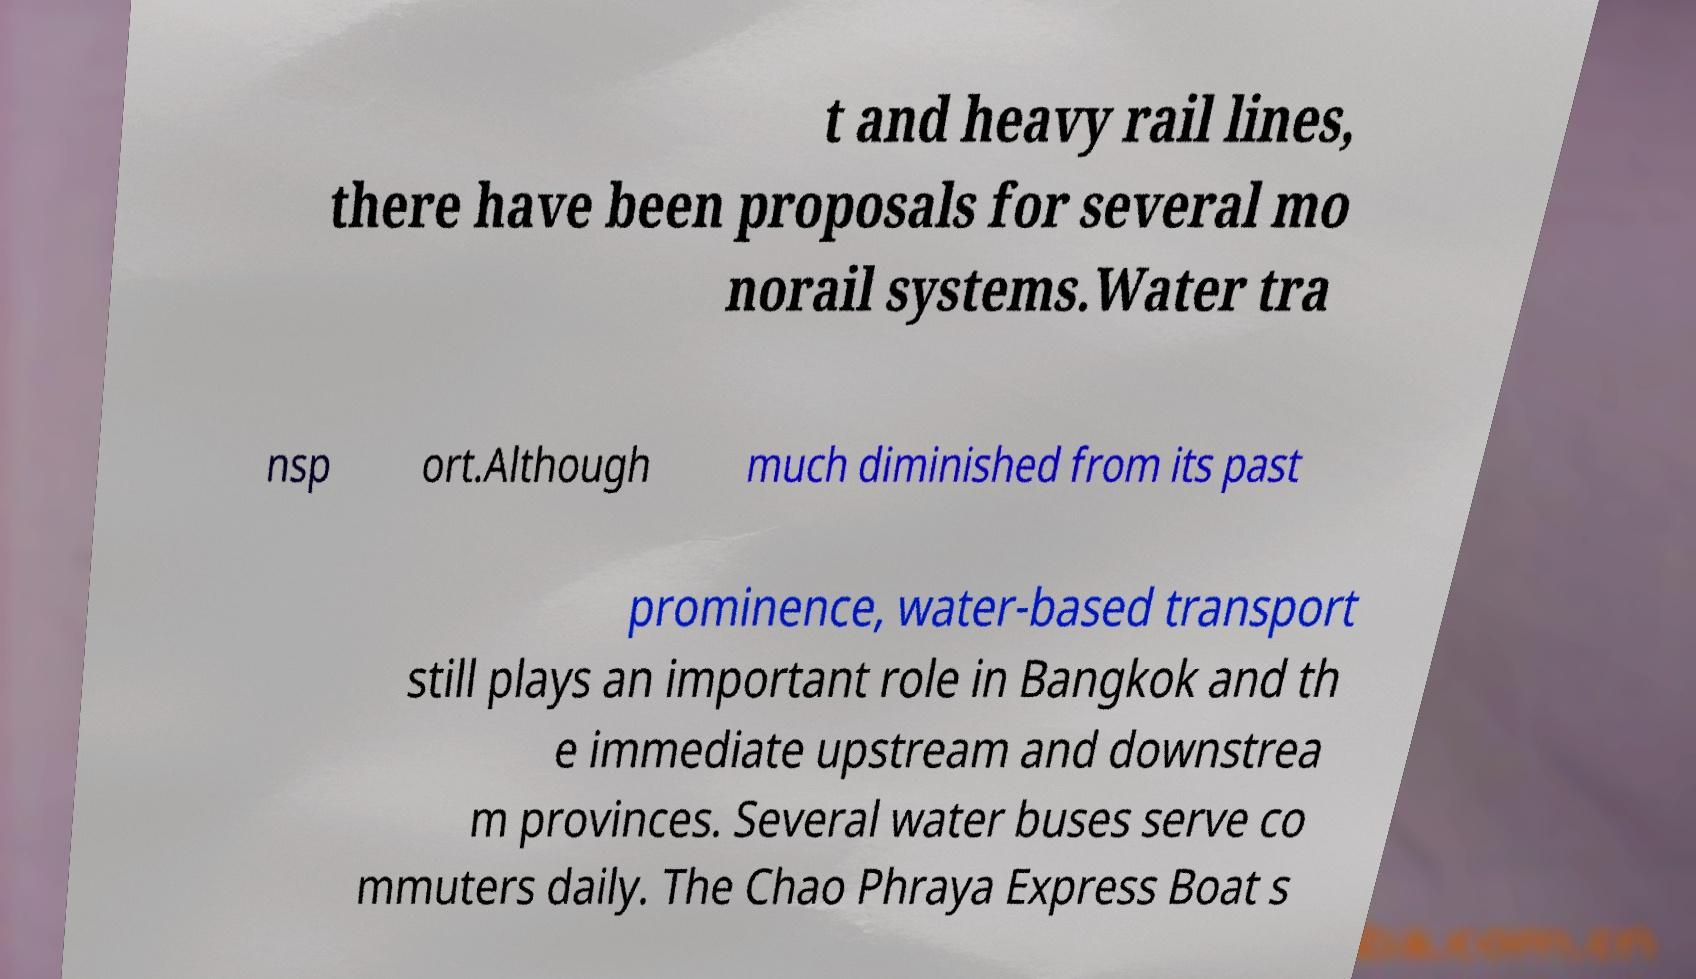There's text embedded in this image that I need extracted. Can you transcribe it verbatim? t and heavy rail lines, there have been proposals for several mo norail systems.Water tra nsp ort.Although much diminished from its past prominence, water-based transport still plays an important role in Bangkok and th e immediate upstream and downstrea m provinces. Several water buses serve co mmuters daily. The Chao Phraya Express Boat s 